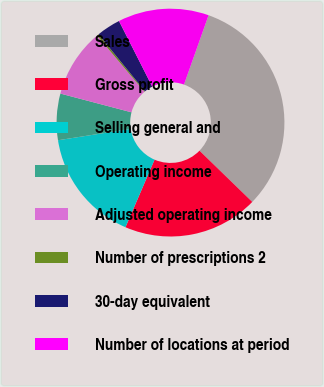Convert chart to OTSL. <chart><loc_0><loc_0><loc_500><loc_500><pie_chart><fcel>Sales<fcel>Gross profit<fcel>Selling general and<fcel>Operating income<fcel>Adjusted operating income<fcel>Number of prescriptions 2<fcel>30-day equivalent<fcel>Number of locations at period<nl><fcel>31.84%<fcel>19.21%<fcel>16.05%<fcel>6.58%<fcel>9.74%<fcel>0.27%<fcel>3.42%<fcel>12.89%<nl></chart> 